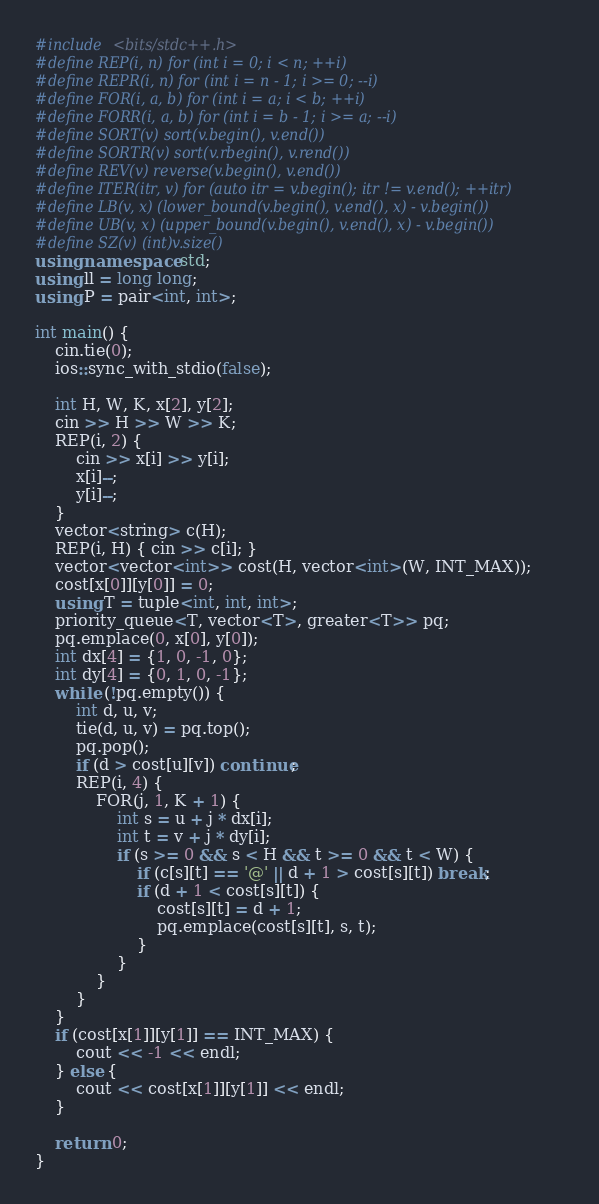<code> <loc_0><loc_0><loc_500><loc_500><_C++_>#include <bits/stdc++.h>
#define REP(i, n) for (int i = 0; i < n; ++i)
#define REPR(i, n) for (int i = n - 1; i >= 0; --i)
#define FOR(i, a, b) for (int i = a; i < b; ++i)
#define FORR(i, a, b) for (int i = b - 1; i >= a; --i)
#define SORT(v) sort(v.begin(), v.end())
#define SORTR(v) sort(v.rbegin(), v.rend())
#define REV(v) reverse(v.begin(), v.end())
#define ITER(itr, v) for (auto itr = v.begin(); itr != v.end(); ++itr)
#define LB(v, x) (lower_bound(v.begin(), v.end(), x) - v.begin())
#define UB(v, x) (upper_bound(v.begin(), v.end(), x) - v.begin())
#define SZ(v) (int)v.size()
using namespace std;
using ll = long long;
using P = pair<int, int>;

int main() {
	cin.tie(0);
	ios::sync_with_stdio(false);

	int H, W, K, x[2], y[2];
	cin >> H >> W >> K;
	REP(i, 2) {
		cin >> x[i] >> y[i];
		x[i]--;
		y[i]--;
	}
	vector<string> c(H);
	REP(i, H) { cin >> c[i]; }
	vector<vector<int>> cost(H, vector<int>(W, INT_MAX));
	cost[x[0]][y[0]] = 0;
	using T = tuple<int, int, int>;
	priority_queue<T, vector<T>, greater<T>> pq;
	pq.emplace(0, x[0], y[0]);
	int dx[4] = {1, 0, -1, 0};
	int dy[4] = {0, 1, 0, -1};
	while (!pq.empty()) {
		int d, u, v;
		tie(d, u, v) = pq.top();
		pq.pop();
		if (d > cost[u][v]) continue;
		REP(i, 4) {
			FOR(j, 1, K + 1) {
				int s = u + j * dx[i];
				int t = v + j * dy[i];
				if (s >= 0 && s < H && t >= 0 && t < W) {
					if (c[s][t] == '@' || d + 1 > cost[s][t]) break;
					if (d + 1 < cost[s][t]) {
						cost[s][t] = d + 1;
						pq.emplace(cost[s][t], s, t);
					}
				}
			}
		}
	}
	if (cost[x[1]][y[1]] == INT_MAX) {
		cout << -1 << endl;
	} else {
		cout << cost[x[1]][y[1]] << endl;
	}

	return 0;
}
</code> 